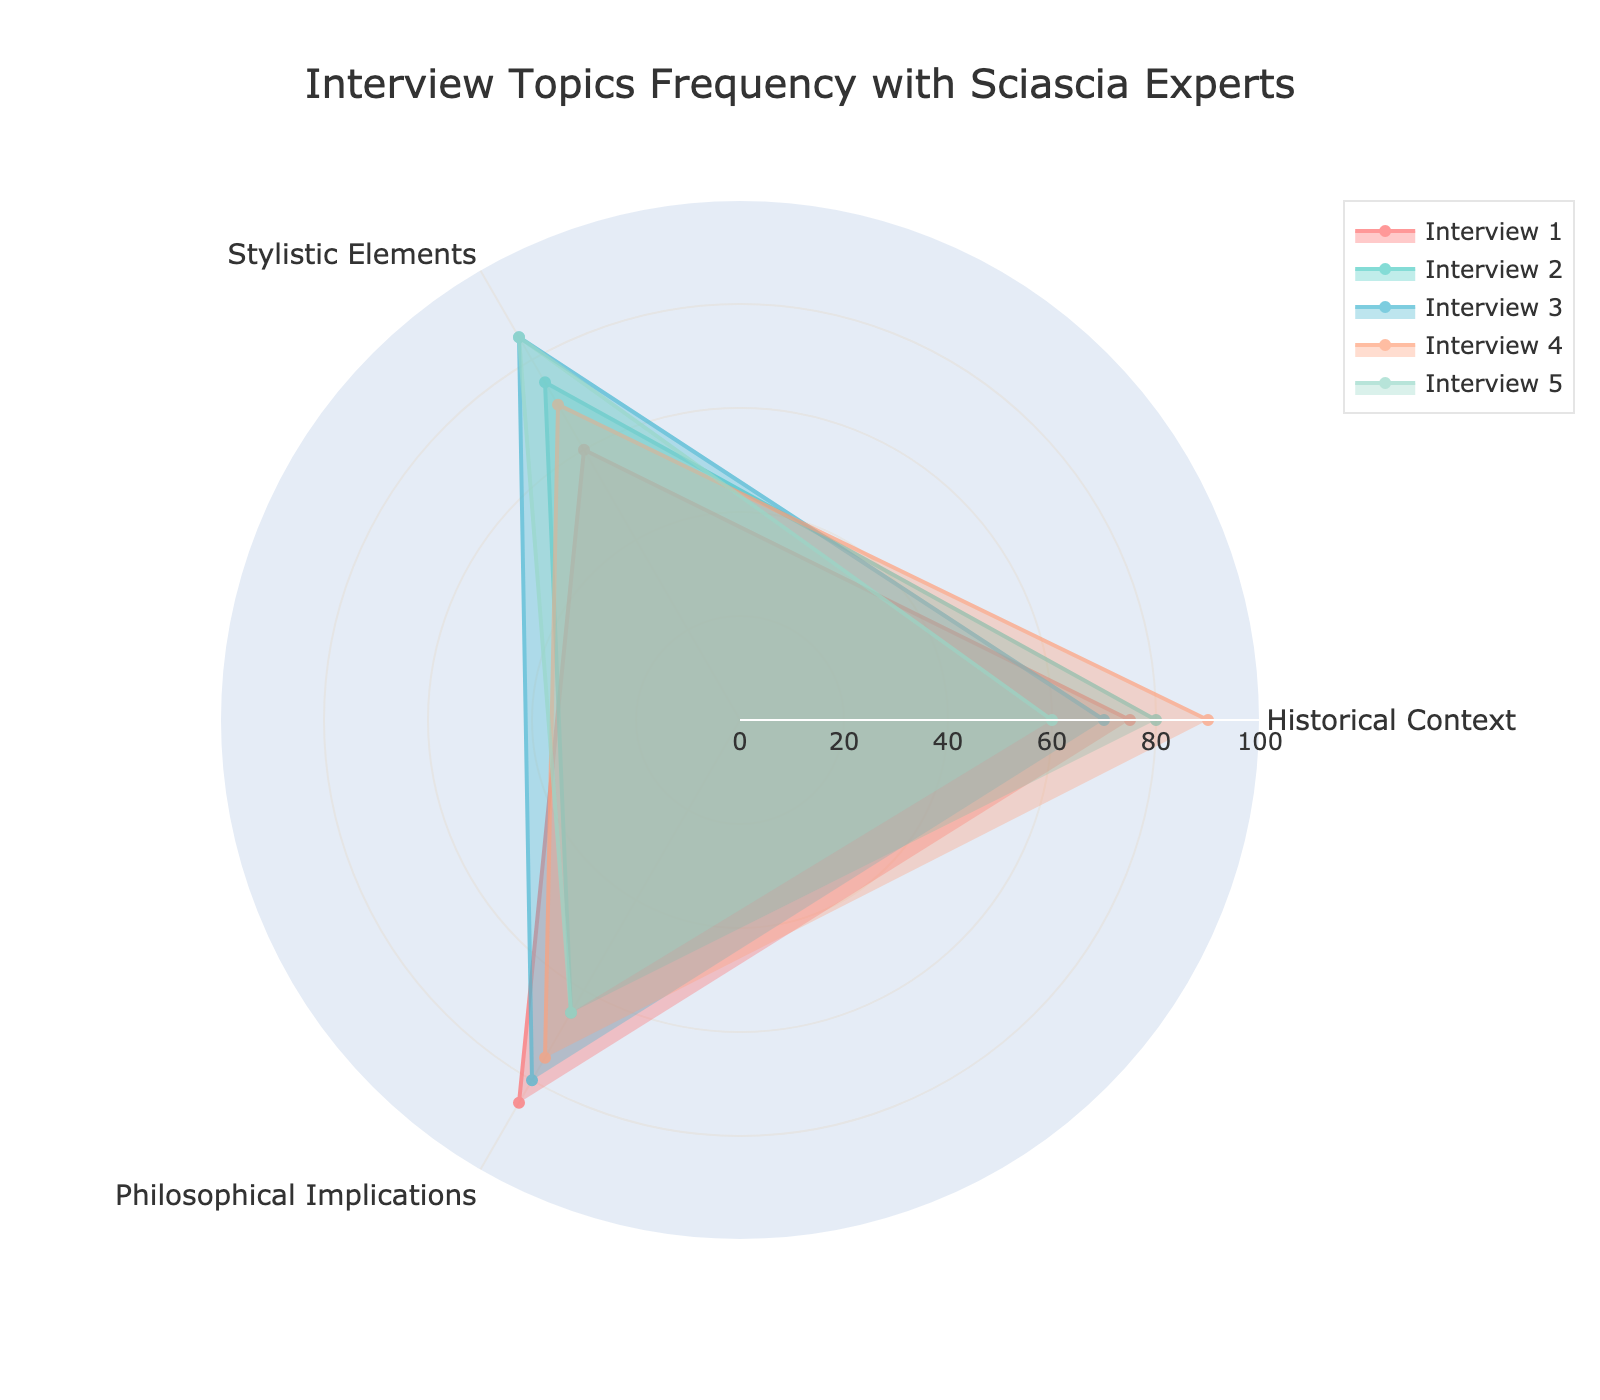How many topics are covered in the radar chart? Looking at the figure, we see three distinct points on the radar chart corresponding to different topics: Historical Context, Stylistic Elements, and Philosophical Implications.
Answer: 3 Which interview had the highest focus on Historical Context? By checking the data on the radar chart for the Historical Context axis, we see that Interview 4 has the highest value, which is 90.
Answer: Interview 4 What is the average frequency of Stylistic Elements across all interviews? The values for Stylistic Elements are 60, 75, 85, 70, and 85. Adding these up gives 375. Dividing by the number of interviews (5) gives 75.
Answer: 75 Which interview discussed Philosophical Implications the least? Observing the data points on the Philosophical Implications axis, the lowest value is 65, shared by Interviews 2 and 5.
Answer: Interviews 2 and 5 Which interview has the most balanced discussion across all topics? To determine this, we look for the interview with the smallest range (difference between the highest and lowest value) across all three topics. Interview 5 has values of 60, 85, and 65, with a range of 25. Checking other interviews, Interview 3 also seems balanced with values of 70, 85, and 80, and a range of 15, which is the smallest range.
Answer: Interview 3 What is the difference in the frequency of Historical Context between Interview 1 and Interview 4? The value for Historical Context in Interview 1 is 75, and in Interview 4, it is 90. Subtracting 75 from 90 gives 15.
Answer: 15 For Interview 2, what is the difference in frequency between Stylistic Elements and Philosophical Implications? The values for Interview 2 are 75 for Stylistic Elements and 65 for Philosophical Implications. Subtracting 65 from 75 gives 10.
Answer: 10 What is the total frequency value of all topics discussed in Interview 5? Adding the values for Interview 5's topics: 60 (Historical Context), 85 (Stylistic Elements), and 65 (Philosophical Implications) gives a total of 210.
Answer: 210 Which interview has the widest spread of frequencies across the topics? To find the widest spread, we calculate the range for each interview. For example, Interview 1 has a range of 25 (85-60). Similarly, for Interview 2, it's 15 (80-65); for Interview 3, it's 15 (85-70); for Interview 4, it's 20 (90-70); and for Interview 5, it's 25 (85-60). Interview 1 and Interview 5 both have the widest spread with a range of 25.
Answer: Interviews 1 and 5 Which topic has the highest average frequency across all interviews? We compute the average for each topic. For Historical Context: (75+80+70+90+60)/5 = 75, for Stylistic Elements: (60+75+85+70+85)/5 = 75, and for Philosophical Implications: (85+65+80+75+65)/5 = 74. Hence, Historical Context and Stylistic Elements have the highest average frequencies.
Answer: Historical Context and Stylistic Elements 